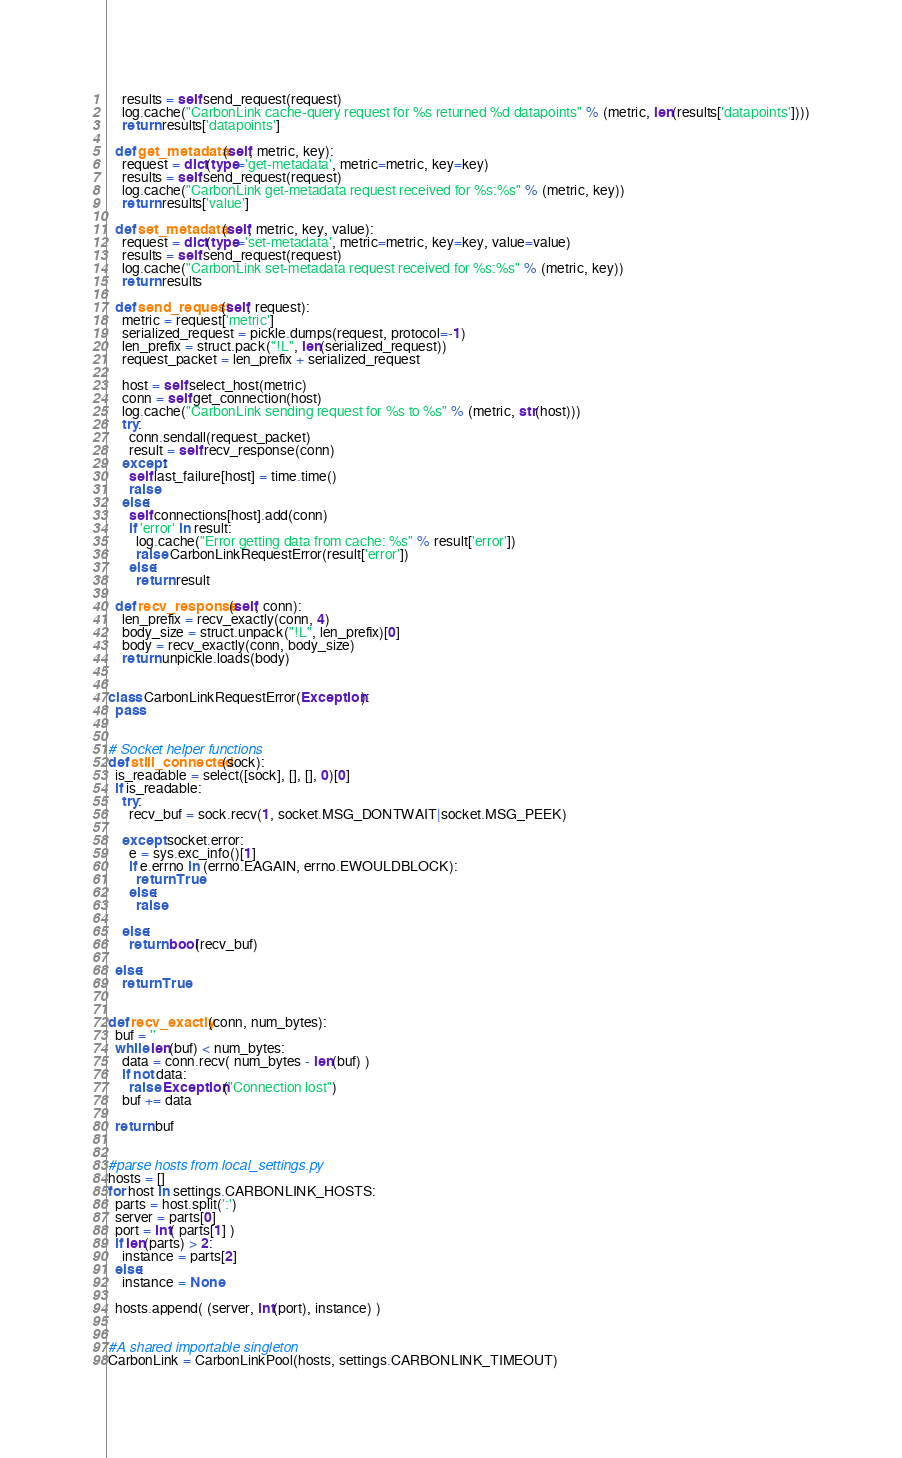Convert code to text. <code><loc_0><loc_0><loc_500><loc_500><_Python_>    results = self.send_request(request)
    log.cache("CarbonLink cache-query request for %s returned %d datapoints" % (metric, len(results['datapoints'])))
    return results['datapoints']

  def get_metadata(self, metric, key):
    request = dict(type='get-metadata', metric=metric, key=key)
    results = self.send_request(request)
    log.cache("CarbonLink get-metadata request received for %s:%s" % (metric, key))
    return results['value']

  def set_metadata(self, metric, key, value):
    request = dict(type='set-metadata', metric=metric, key=key, value=value)
    results = self.send_request(request)
    log.cache("CarbonLink set-metadata request received for %s:%s" % (metric, key))
    return results

  def send_request(self, request):
    metric = request['metric']
    serialized_request = pickle.dumps(request, protocol=-1)
    len_prefix = struct.pack("!L", len(serialized_request))
    request_packet = len_prefix + serialized_request

    host = self.select_host(metric)
    conn = self.get_connection(host)
    log.cache("CarbonLink sending request for %s to %s" % (metric, str(host)))
    try:
      conn.sendall(request_packet)
      result = self.recv_response(conn)
    except:
      self.last_failure[host] = time.time()
      raise
    else:
      self.connections[host].add(conn)
      if 'error' in result:
        log.cache("Error getting data from cache: %s" % result['error'])
        raise CarbonLinkRequestError(result['error'])
      else:
        return result

  def recv_response(self, conn):
    len_prefix = recv_exactly(conn, 4)
    body_size = struct.unpack("!L", len_prefix)[0]
    body = recv_exactly(conn, body_size)
    return unpickle.loads(body)


class CarbonLinkRequestError(Exception):
  pass


# Socket helper functions
def still_connected(sock):
  is_readable = select([sock], [], [], 0)[0]
  if is_readable:
    try:
      recv_buf = sock.recv(1, socket.MSG_DONTWAIT|socket.MSG_PEEK)

    except socket.error:
      e = sys.exc_info()[1]
      if e.errno in (errno.EAGAIN, errno.EWOULDBLOCK):
        return True
      else:
        raise

    else:
      return bool(recv_buf)

  else:
    return True


def recv_exactly(conn, num_bytes):
  buf = ''
  while len(buf) < num_bytes:
    data = conn.recv( num_bytes - len(buf) )
    if not data:
      raise Exception("Connection lost")
    buf += data

  return buf


#parse hosts from local_settings.py
hosts = []
for host in settings.CARBONLINK_HOSTS:
  parts = host.split(':')
  server = parts[0]
  port = int( parts[1] )
  if len(parts) > 2:
    instance = parts[2]
  else:
    instance = None

  hosts.append( (server, int(port), instance) )


#A shared importable singleton
CarbonLink = CarbonLinkPool(hosts, settings.CARBONLINK_TIMEOUT)
</code> 